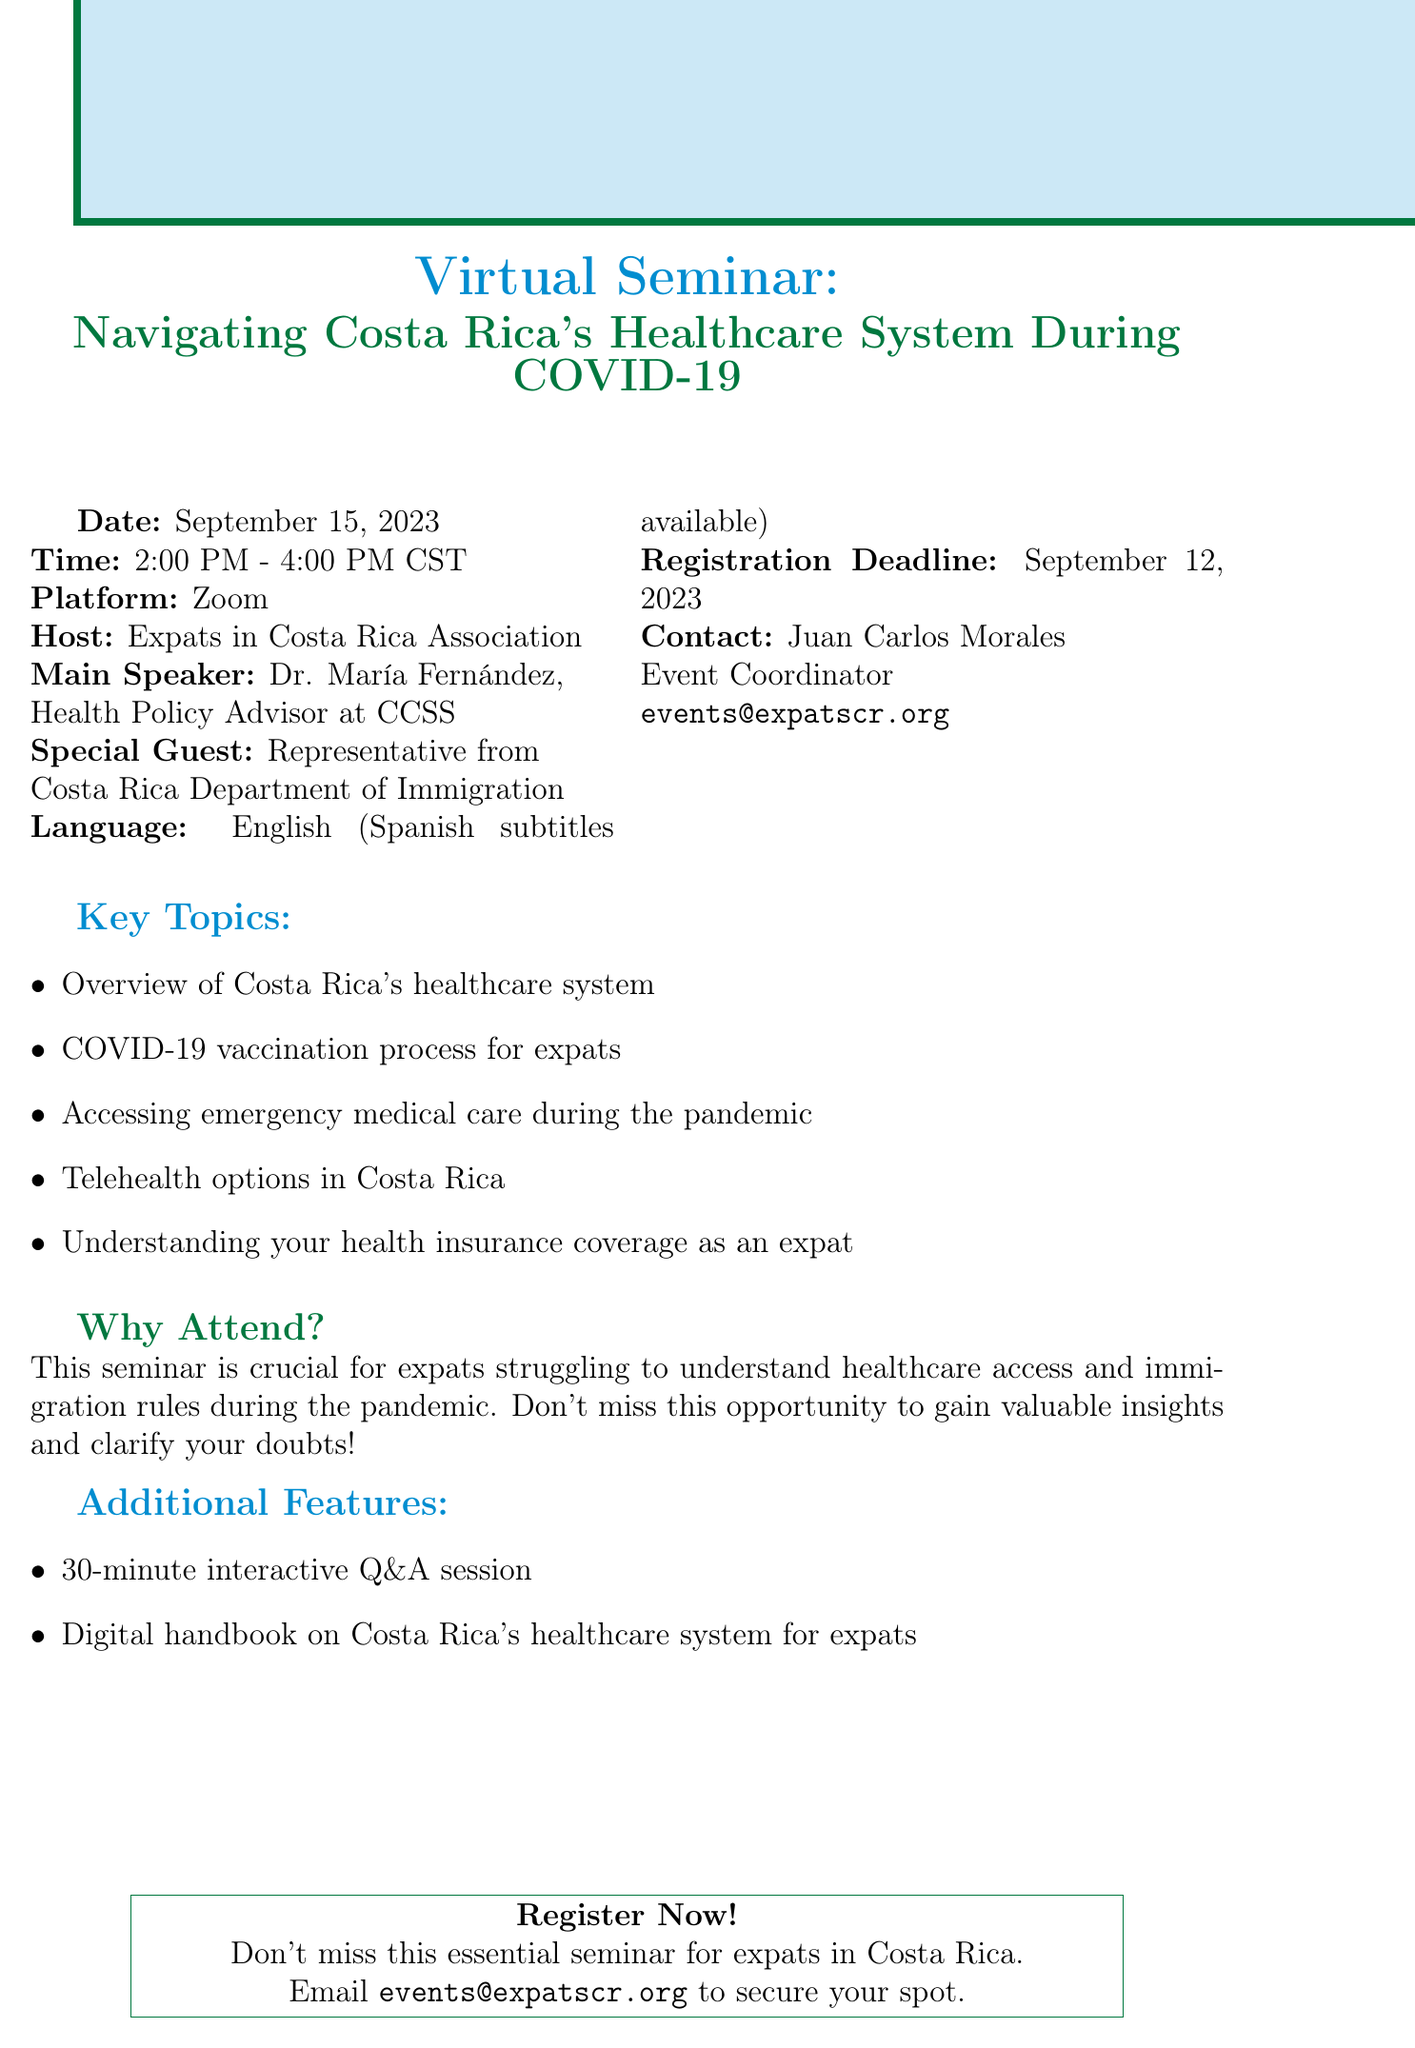What is the date of the seminar? The document states the seminar is scheduled for September 15, 2023.
Answer: September 15, 2023 Who is the main speaker? According to the document, the main speaker is Dr. María Fernández.
Answer: Dr. María Fernández What time does the seminar start? The seminar starts at 2:00 PM CST, as noted in the document.
Answer: 2:00 PM What is the deadline for registration? The document specifies the registration deadline is September 12, 2023.
Answer: September 12, 2023 How long is the Q&A session? The document indicates that the Q&A session lasts 30 minutes.
Answer: 30 minutes What language will the seminar be conducted in? The document mentions that the seminar will be conducted in English.
Answer: English What is one of the key topics covered? The document lists several topics, including the COVID-19 vaccination process for expats.
Answer: COVID-19 vaccination process for expats Who is hosting the seminar? The host organization mentioned in the document is the Expats in Costa Rica Association.
Answer: Expats in Costa Rica Association What resource is provided to attendees? The document states that a digital handbook on Costa Rica's healthcare system will be provided.
Answer: Digital handbook on Costa Rica's healthcare system for expats 